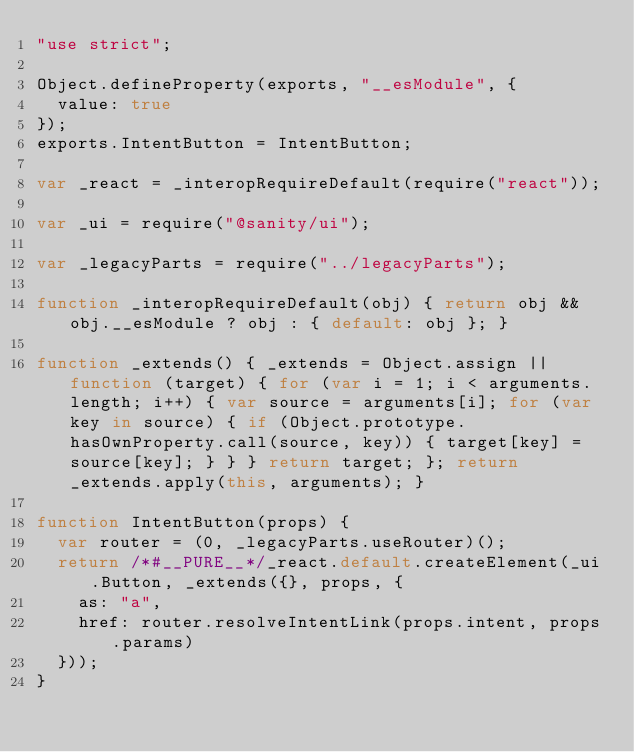Convert code to text. <code><loc_0><loc_0><loc_500><loc_500><_JavaScript_>"use strict";

Object.defineProperty(exports, "__esModule", {
  value: true
});
exports.IntentButton = IntentButton;

var _react = _interopRequireDefault(require("react"));

var _ui = require("@sanity/ui");

var _legacyParts = require("../legacyParts");

function _interopRequireDefault(obj) { return obj && obj.__esModule ? obj : { default: obj }; }

function _extends() { _extends = Object.assign || function (target) { for (var i = 1; i < arguments.length; i++) { var source = arguments[i]; for (var key in source) { if (Object.prototype.hasOwnProperty.call(source, key)) { target[key] = source[key]; } } } return target; }; return _extends.apply(this, arguments); }

function IntentButton(props) {
  var router = (0, _legacyParts.useRouter)();
  return /*#__PURE__*/_react.default.createElement(_ui.Button, _extends({}, props, {
    as: "a",
    href: router.resolveIntentLink(props.intent, props.params)
  }));
}</code> 